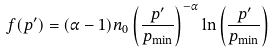<formula> <loc_0><loc_0><loc_500><loc_500>f ( p ^ { \prime } ) = ( \alpha - 1 ) n _ { 0 } \left ( \frac { p ^ { \prime } } { p _ { \min } } \right ) ^ { - \alpha } \ln \left ( \frac { p ^ { \prime } } { p _ { \min } } \right )</formula> 